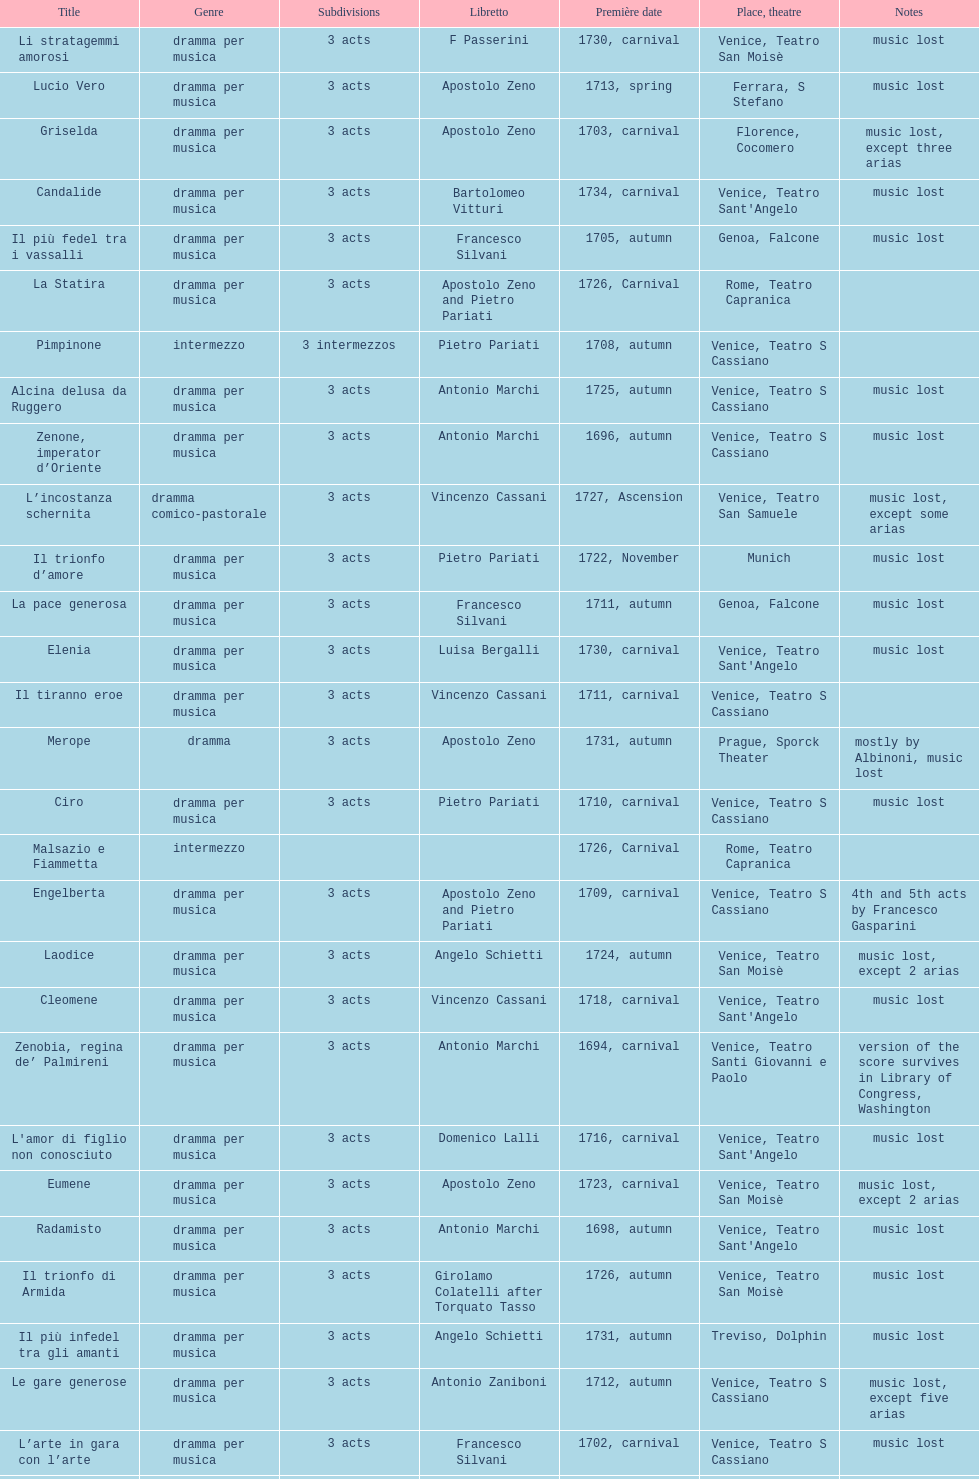Give me the full table as a dictionary. {'header': ['Title', 'Genre', 'Sub\xaddivisions', 'Libretto', 'Première date', 'Place, theatre', 'Notes'], 'rows': [['Li stratagemmi amorosi', 'dramma per musica', '3 acts', 'F Passerini', '1730, carnival', 'Venice, Teatro San Moisè', 'music lost'], ['Lucio Vero', 'dramma per musica', '3 acts', 'Apostolo Zeno', '1713, spring', 'Ferrara, S Stefano', 'music lost'], ['Griselda', 'dramma per musica', '3 acts', 'Apostolo Zeno', '1703, carnival', 'Florence, Cocomero', 'music lost, except three arias'], ['Candalide', 'dramma per musica', '3 acts', 'Bartolomeo Vitturi', '1734, carnival', "Venice, Teatro Sant'Angelo", 'music lost'], ['Il più fedel tra i vassalli', 'dramma per musica', '3 acts', 'Francesco Silvani', '1705, autumn', 'Genoa, Falcone', 'music lost'], ['La Statira', 'dramma per musica', '3 acts', 'Apostolo Zeno and Pietro Pariati', '1726, Carnival', 'Rome, Teatro Capranica', ''], ['Pimpinone', 'intermezzo', '3 intermezzos', 'Pietro Pariati', '1708, autumn', 'Venice, Teatro S Cassiano', ''], ['Alcina delusa da Ruggero', 'dramma per musica', '3 acts', 'Antonio Marchi', '1725, autumn', 'Venice, Teatro S Cassiano', 'music lost'], ['Zenone, imperator d’Oriente', 'dramma per musica', '3 acts', 'Antonio Marchi', '1696, autumn', 'Venice, Teatro S Cassiano', 'music lost'], ['L’incostanza schernita', 'dramma comico-pastorale', '3 acts', 'Vincenzo Cassani', '1727, Ascension', 'Venice, Teatro San Samuele', 'music lost, except some arias'], ['Il trionfo d’amore', 'dramma per musica', '3 acts', 'Pietro Pariati', '1722, November', 'Munich', 'music lost'], ['La pace generosa', 'dramma per musica', '3 acts', 'Francesco Silvani', '1711, autumn', 'Genoa, Falcone', 'music lost'], ['Elenia', 'dramma per musica', '3 acts', 'Luisa Bergalli', '1730, carnival', "Venice, Teatro Sant'Angelo", 'music lost'], ['Il tiranno eroe', 'dramma per musica', '3 acts', 'Vincenzo Cassani', '1711, carnival', 'Venice, Teatro S Cassiano', ''], ['Merope', 'dramma', '3 acts', 'Apostolo Zeno', '1731, autumn', 'Prague, Sporck Theater', 'mostly by Albinoni, music lost'], ['Ciro', 'dramma per musica', '3 acts', 'Pietro Pariati', '1710, carnival', 'Venice, Teatro S Cassiano', 'music lost'], ['Malsazio e Fiammetta', 'intermezzo', '', '', '1726, Carnival', 'Rome, Teatro Capranica', ''], ['Engelberta', 'dramma per musica', '3 acts', 'Apostolo Zeno and Pietro Pariati', '1709, carnival', 'Venice, Teatro S Cassiano', '4th and 5th acts by Francesco Gasparini'], ['Laodice', 'dramma per musica', '3 acts', 'Angelo Schietti', '1724, autumn', 'Venice, Teatro San Moisè', 'music lost, except 2 arias'], ['Cleomene', 'dramma per musica', '3 acts', 'Vincenzo Cassani', '1718, carnival', "Venice, Teatro Sant'Angelo", 'music lost'], ['Zenobia, regina de’ Palmireni', 'dramma per musica', '3 acts', 'Antonio Marchi', '1694, carnival', 'Venice, Teatro Santi Giovanni e Paolo', 'version of the score survives in Library of Congress, Washington'], ["L'amor di figlio non conosciuto", 'dramma per musica', '3 acts', 'Domenico Lalli', '1716, carnival', "Venice, Teatro Sant'Angelo", 'music lost'], ['Eumene', 'dramma per musica', '3 acts', 'Apostolo Zeno', '1723, carnival', 'Venice, Teatro San Moisè', 'music lost, except 2 arias'], ['Radamisto', 'dramma per musica', '3 acts', 'Antonio Marchi', '1698, autumn', "Venice, Teatro Sant'Angelo", 'music lost'], ['Il trionfo di Armida', 'dramma per musica', '3 acts', 'Girolamo Colatelli after Torquato Tasso', '1726, autumn', 'Venice, Teatro San Moisè', 'music lost'], ['Il più infedel tra gli amanti', 'dramma per musica', '3 acts', 'Angelo Schietti', '1731, autumn', 'Treviso, Dolphin', 'music lost'], ['Le gare generose', 'dramma per musica', '3 acts', 'Antonio Zaniboni', '1712, autumn', 'Venice, Teatro S Cassiano', 'music lost, except five arias'], ['L’arte in gara con l’arte', 'dramma per musica', '3 acts', 'Francesco Silvani', '1702, carnival', 'Venice, Teatro S Cassiano', 'music lost'], ['I rivali generosi', 'dramma per musica', '3 acts', 'Apostolo Zeno', '1725', 'Brescia, Nuovo', ''], ['L’ingratitudine castigata', 'dramma per musica', '3 acts', 'Francesco Silvani', '1698, carnival', 'Venice, Teatro S Cassiano', 'music lost'], ['Astarto', 'dramma per musica', '3 acts', 'Apostolo Zeno and Pietro Pariati', '1708, autumn', 'Venice, Teatro S Cassiano', 'music lost, except some arias'], ['Eumene', 'dramma per musica', '3 acts', 'Antonio Salvi', '1717, autumn', 'Venice, Teatro San Giovanni Grisostomo', 'music lost, except one aria'], ["L'impresario delle Isole Canarie", 'intermezzo', '2 acts', 'Metastasio', '1725, carnival', 'Venice, Teatro S Cassiano', 'music lost'], ['L’inganno innocente', 'dramma per musica', '3 acts', 'Francesco Silvani', '1701, carnival', "Venice, Teatro Sant'Angelo", 'music lost, except some arias'], ['Artamene', 'dramma per musica', '3 acts', 'Bartolomeo Vitturi', '1741, carnival', "Venice, Teatro Sant'Angelo", 'music lost'], ['Meleagro', 'dramma per musica', '3 acts', 'Pietro Antonio Bernardoni', '1718, carnival', "Venice, Teatro Sant'Angelo", 'music lost'], ['Il Giustino', 'dramma per musica', '5 acts', 'Pietro Pariati after Nicolò Beregan', '1711, spring', 'Bologna, Formagliari', 'music lost'], ['Ardelinda', 'dramma', '3 acts', 'Bartolomeo Vitturi', '1732, autumn', "Venice, Teatro Sant'Angelo", 'music lost, except five arias'], ['Il prodigio dell’innocenza', 'dramma', '3 acts', 'Fulgenzio Maria Gualazzi', '1695, carnival', 'Venice, Teatro Santi Giovanni e Paolo', 'music lost'], ['Aminta', 'dramma regio pastorale', '3 acts', 'Apostolo Zeno', '1703, autumn', 'Florence, Cocomero', 'music lost'], ['Le due rivali in amore', 'dramma per musica', '3 acts', 'Aurelio Aureli', '1728, autumn', 'Venice, Teatro San Moisè', 'music lost'], ['Il tradimento tradito', 'dramma per musica', '3 acts', 'Francesco Silvani', '1708, carnival', "Venice, Teatro Sant'Angelo", 'music lost'], ['Ermengarda', 'dramma per musica', '3 acts', 'Antonio Maria Lucchini', '1723, autumn', 'Venice, Teatro San Moisè', 'music lost'], ['Il Satrapone', 'intermezzo', '', 'Salvi', '1729', 'Parma, Omodeo', ''], ['La fede tra gl’inganni', 'dramma per musica', '3 acts', 'Francesco Silvani', '1707, Carnival', "Venice, Teatro Sant'Angelo", 'music lost'], ['Il Tigrane, re d’Armenia', 'dramma per musica', '3 acts', 'Giulio Cesare Corradi', '1697, carnival', 'Venice, Teatro S Cassiano', 'music lost'], ['Diomede punito da Alcide', 'dramma', '3 acts', 'Aurelio Aureli', '1700, autumn', "Venice, Teatro Sant'Angelo", 'music lost'], ['Primislao, primo re di Boemia', 'dramma per musica', '3 acts', 'Giulio Cesare Corradi', '1697, autumn', 'Venice, Teatro S Cassiano', 'music lost'], ['La fortezza al cimento', 'melodramma', '2 acts', 'Francesco Silvani', '1707', 'Piacenza, Ducale', 'music lost'], ['Scipione nelle Spagne', 'dramma per musica', '3 acts', 'Apostolo Zeno', '1724, Ascension', 'Venice, Teatro San Samuele', 'music lost'], ['Didone abbandonata', 'tragedia', '3 acts', 'Metastasio', '1725, carnival', 'Venice, Teatro S Cassiano', 'music lost'], ['Gli eccessi della gelosia', 'dramma per musica', '3 acts', 'Domenico Lalli', '1722, carnival', "Venice, Teatro Sant'Angelo", 'music lost, except some arias'], ['Antigono, tutore di Filippo, re di Macedonia', 'tragedia', '5 acts', 'Giovanni Piazzon', '1724, carnival', 'Venice, Teatro San Moisè', '5th act by Giovanni Porta, music lost'], ['I veri amici', 'dramma per musica', '3 acts', 'Francesco Silvani and Domenico Lalli after Pierre Corneille', '1722, October', 'Munich, Hof', 'music lost, except some arias'], ['La prosperità di Elio Sejano', 'dramma per musica', '3 acts', 'Nicolò Minato', '1707, carnival', 'Genoa, Falcone', 'music lost']]} How many operas on this list has at least 3 acts? 51. 